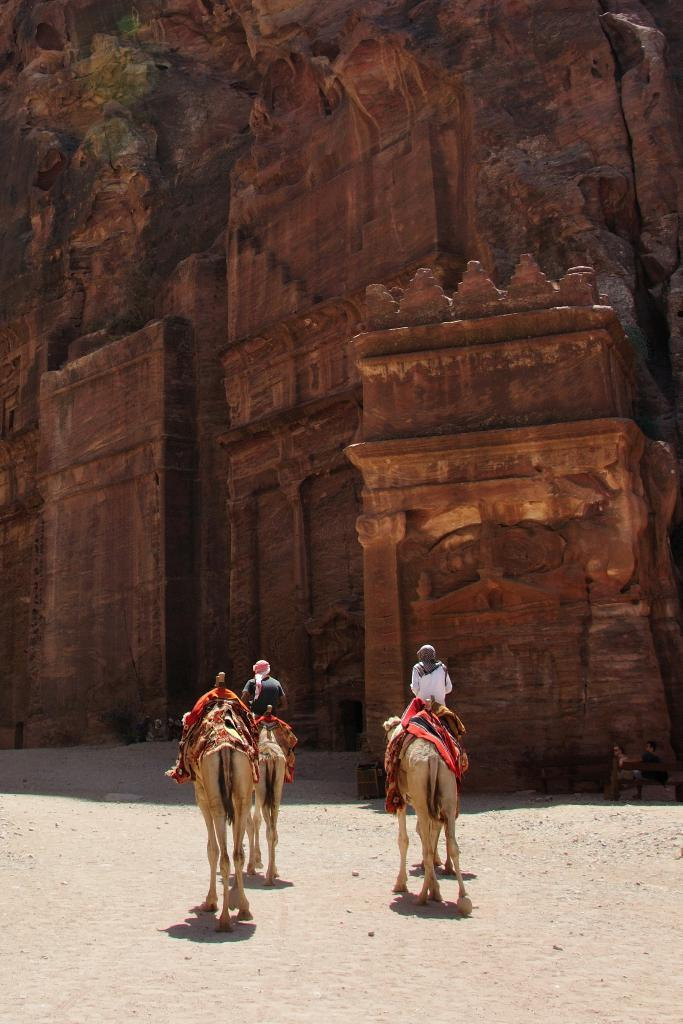How many camels are in the image? There are three camels in the image. Are there any people riding the camels? Yes, two persons are sitting on two of the camels. What else can be seen in the image besides the camels and people? There is a building visible in the image. Can you see a bike being ridden by someone in the image? No, there is no bike present in the image. 